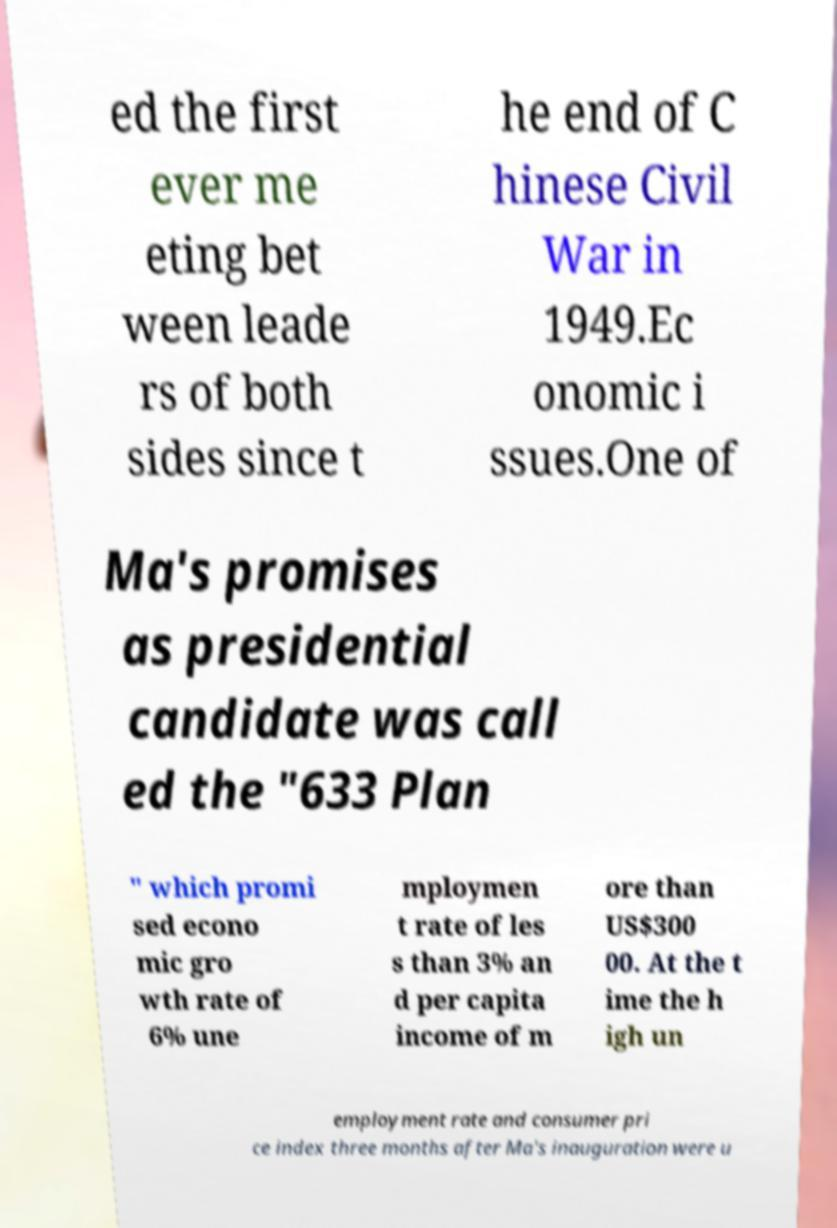What messages or text are displayed in this image? I need them in a readable, typed format. ed the first ever me eting bet ween leade rs of both sides since t he end of C hinese Civil War in 1949.Ec onomic i ssues.One of Ma's promises as presidential candidate was call ed the "633 Plan " which promi sed econo mic gro wth rate of 6% une mploymen t rate of les s than 3% an d per capita income of m ore than US$300 00. At the t ime the h igh un employment rate and consumer pri ce index three months after Ma's inauguration were u 